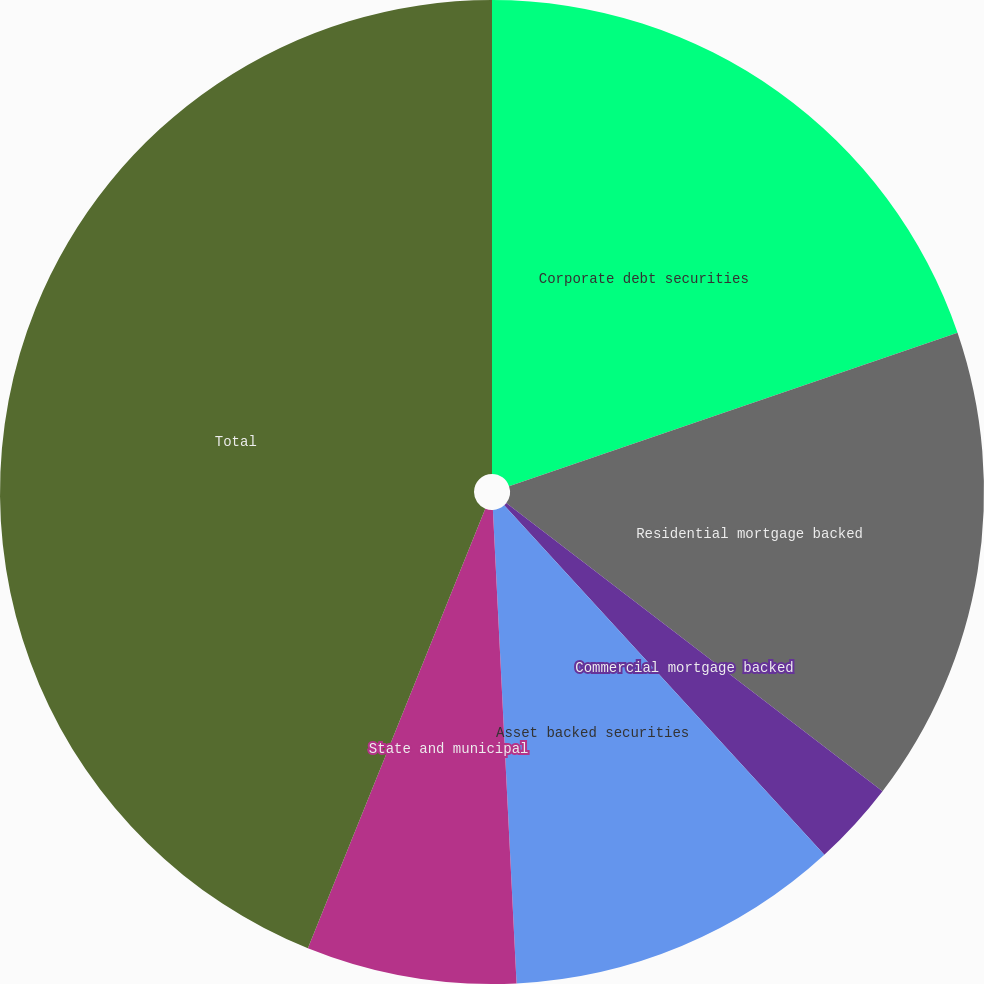Convert chart. <chart><loc_0><loc_0><loc_500><loc_500><pie_chart><fcel>Corporate debt securities<fcel>Residential mortgage backed<fcel>Commercial mortgage backed<fcel>Asset backed securities<fcel>State and municipal<fcel>Total<nl><fcel>19.76%<fcel>15.65%<fcel>2.79%<fcel>11.01%<fcel>6.9%<fcel>43.9%<nl></chart> 